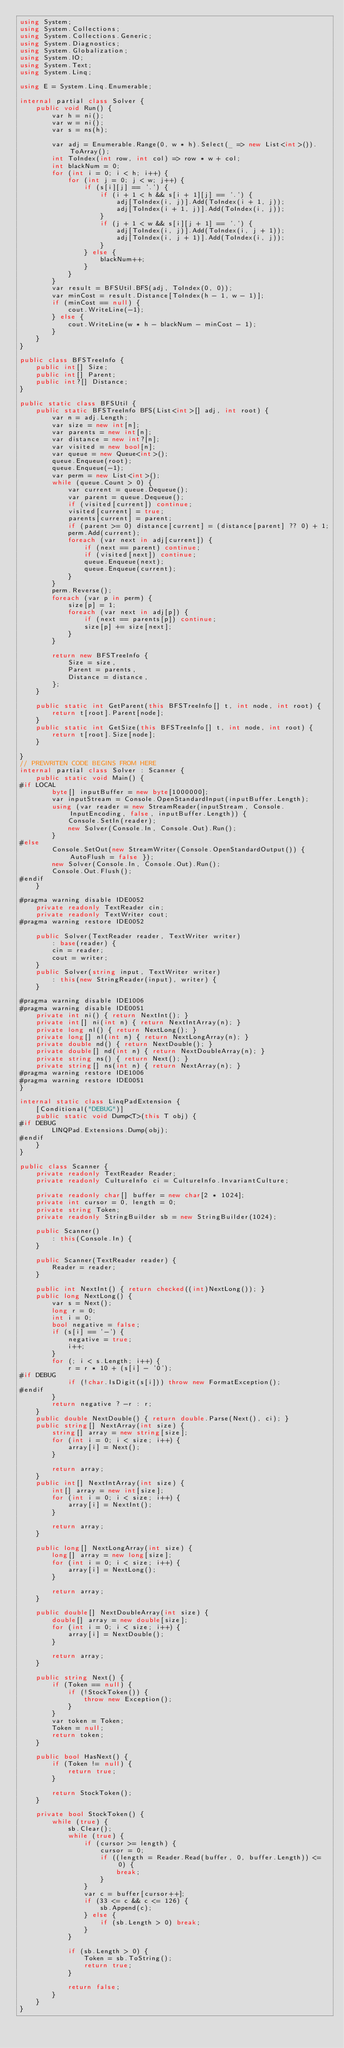<code> <loc_0><loc_0><loc_500><loc_500><_C#_>using System;
using System.Collections;
using System.Collections.Generic;
using System.Diagnostics;
using System.Globalization;
using System.IO;
using System.Text;
using System.Linq;

using E = System.Linq.Enumerable;

internal partial class Solver {
    public void Run() {
        var h = ni();
        var w = ni();
        var s = ns(h);

        var adj = Enumerable.Range(0, w * h).Select(_ => new List<int>()).ToArray();
        int ToIndex(int row, int col) => row * w + col;
        int blackNum = 0;
        for (int i = 0; i < h; i++) {
            for (int j = 0; j < w; j++) {
                if (s[i][j] == '.') {
                    if (i + 1 < h && s[i + 1][j] == '.') {
                        adj[ToIndex(i, j)].Add(ToIndex(i + 1, j));
                        adj[ToIndex(i + 1, j)].Add(ToIndex(i, j));
                    }
                    if (j + 1 < w && s[i][j + 1] == '.') {
                        adj[ToIndex(i, j)].Add(ToIndex(i, j + 1));
                        adj[ToIndex(i, j + 1)].Add(ToIndex(i, j));
                    }
                } else {
                    blackNum++;
                }
            }
        }
        var result = BFSUtil.BFS(adj, ToIndex(0, 0));
        var minCost = result.Distance[ToIndex(h - 1, w - 1)];
        if (minCost == null) {
            cout.WriteLine(-1);
        } else {
            cout.WriteLine(w * h - blackNum - minCost - 1);
        }
    }
}

public class BFSTreeInfo {
    public int[] Size;
    public int[] Parent;
    public int?[] Distance;
}

public static class BFSUtil {
    public static BFSTreeInfo BFS(List<int>[] adj, int root) {
        var n = adj.Length;
        var size = new int[n];
        var parents = new int[n];
        var distance = new int?[n];
        var visited = new bool[n];
        var queue = new Queue<int>();
        queue.Enqueue(root);
        queue.Enqueue(-1);
        var perm = new List<int>();
        while (queue.Count > 0) {
            var current = queue.Dequeue();
            var parent = queue.Dequeue();
            if (visited[current]) continue;
            visited[current] = true;
            parents[current] = parent;
            if (parent >= 0) distance[current] = (distance[parent] ?? 0) + 1;
            perm.Add(current);
            foreach (var next in adj[current]) {
                if (next == parent) continue;
                if (visited[next]) continue;
                queue.Enqueue(next);
                queue.Enqueue(current);
            }
        }
        perm.Reverse();
        foreach (var p in perm) {
            size[p] = 1;
            foreach (var next in adj[p]) {
                if (next == parents[p]) continue;
                size[p] += size[next];
            }
        }

        return new BFSTreeInfo {
            Size = size,
            Parent = parents,
            Distance = distance,
        };
    }

    public static int GetParent(this BFSTreeInfo[] t, int node, int root) {
        return t[root].Parent[node];
    }
    public static int GetSize(this BFSTreeInfo[] t, int node, int root) {
        return t[root].Size[node];
    }

}
// PREWRITEN CODE BEGINS FROM HERE
internal partial class Solver : Scanner {
    public static void Main() {
#if LOCAL
        byte[] inputBuffer = new byte[1000000];
        var inputStream = Console.OpenStandardInput(inputBuffer.Length);
        using (var reader = new StreamReader(inputStream, Console.InputEncoding, false, inputBuffer.Length)) {
            Console.SetIn(reader);
            new Solver(Console.In, Console.Out).Run();
        }
#else
        Console.SetOut(new StreamWriter(Console.OpenStandardOutput()) { AutoFlush = false });
        new Solver(Console.In, Console.Out).Run();
        Console.Out.Flush();
#endif
    }

#pragma warning disable IDE0052
    private readonly TextReader cin;
    private readonly TextWriter cout;
#pragma warning restore IDE0052

    public Solver(TextReader reader, TextWriter writer)
        : base(reader) {
        cin = reader;
        cout = writer;
    }
    public Solver(string input, TextWriter writer)
        : this(new StringReader(input), writer) {
    }

#pragma warning disable IDE1006
#pragma warning disable IDE0051
    private int ni() { return NextInt(); }
    private int[] ni(int n) { return NextIntArray(n); }
    private long nl() { return NextLong(); }
    private long[] nl(int n) { return NextLongArray(n); }
    private double nd() { return NextDouble(); }
    private double[] nd(int n) { return NextDoubleArray(n); }
    private string ns() { return Next(); }
    private string[] ns(int n) { return NextArray(n); }
#pragma warning restore IDE1006
#pragma warning restore IDE0051
}

internal static class LinqPadExtension {
    [Conditional("DEBUG")]
    public static void Dump<T>(this T obj) {
#if DEBUG
        LINQPad.Extensions.Dump(obj);
#endif
    }
}

public class Scanner {
    private readonly TextReader Reader;
    private readonly CultureInfo ci = CultureInfo.InvariantCulture;

    private readonly char[] buffer = new char[2 * 1024];
    private int cursor = 0, length = 0;
    private string Token;
    private readonly StringBuilder sb = new StringBuilder(1024);

    public Scanner()
        : this(Console.In) {
    }

    public Scanner(TextReader reader) {
        Reader = reader;
    }

    public int NextInt() { return checked((int)NextLong()); }
    public long NextLong() {
        var s = Next();
        long r = 0;
        int i = 0;
        bool negative = false;
        if (s[i] == '-') {
            negative = true;
            i++;
        }
        for (; i < s.Length; i++) {
            r = r * 10 + (s[i] - '0');
#if DEBUG
            if (!char.IsDigit(s[i])) throw new FormatException();
#endif
        }
        return negative ? -r : r;
    }
    public double NextDouble() { return double.Parse(Next(), ci); }
    public string[] NextArray(int size) {
        string[] array = new string[size];
        for (int i = 0; i < size; i++) {
            array[i] = Next();
        }

        return array;
    }
    public int[] NextIntArray(int size) {
        int[] array = new int[size];
        for (int i = 0; i < size; i++) {
            array[i] = NextInt();
        }

        return array;
    }

    public long[] NextLongArray(int size) {
        long[] array = new long[size];
        for (int i = 0; i < size; i++) {
            array[i] = NextLong();
        }

        return array;
    }

    public double[] NextDoubleArray(int size) {
        double[] array = new double[size];
        for (int i = 0; i < size; i++) {
            array[i] = NextDouble();
        }

        return array;
    }

    public string Next() {
        if (Token == null) {
            if (!StockToken()) {
                throw new Exception();
            }
        }
        var token = Token;
        Token = null;
        return token;
    }

    public bool HasNext() {
        if (Token != null) {
            return true;
        }

        return StockToken();
    }

    private bool StockToken() {
        while (true) {
            sb.Clear();
            while (true) {
                if (cursor >= length) {
                    cursor = 0;
                    if ((length = Reader.Read(buffer, 0, buffer.Length)) <= 0) {
                        break;
                    }
                }
                var c = buffer[cursor++];
                if (33 <= c && c <= 126) {
                    sb.Append(c);
                } else {
                    if (sb.Length > 0) break;
                }
            }

            if (sb.Length > 0) {
                Token = sb.ToString();
                return true;
            }

            return false;
        }
    }
}</code> 